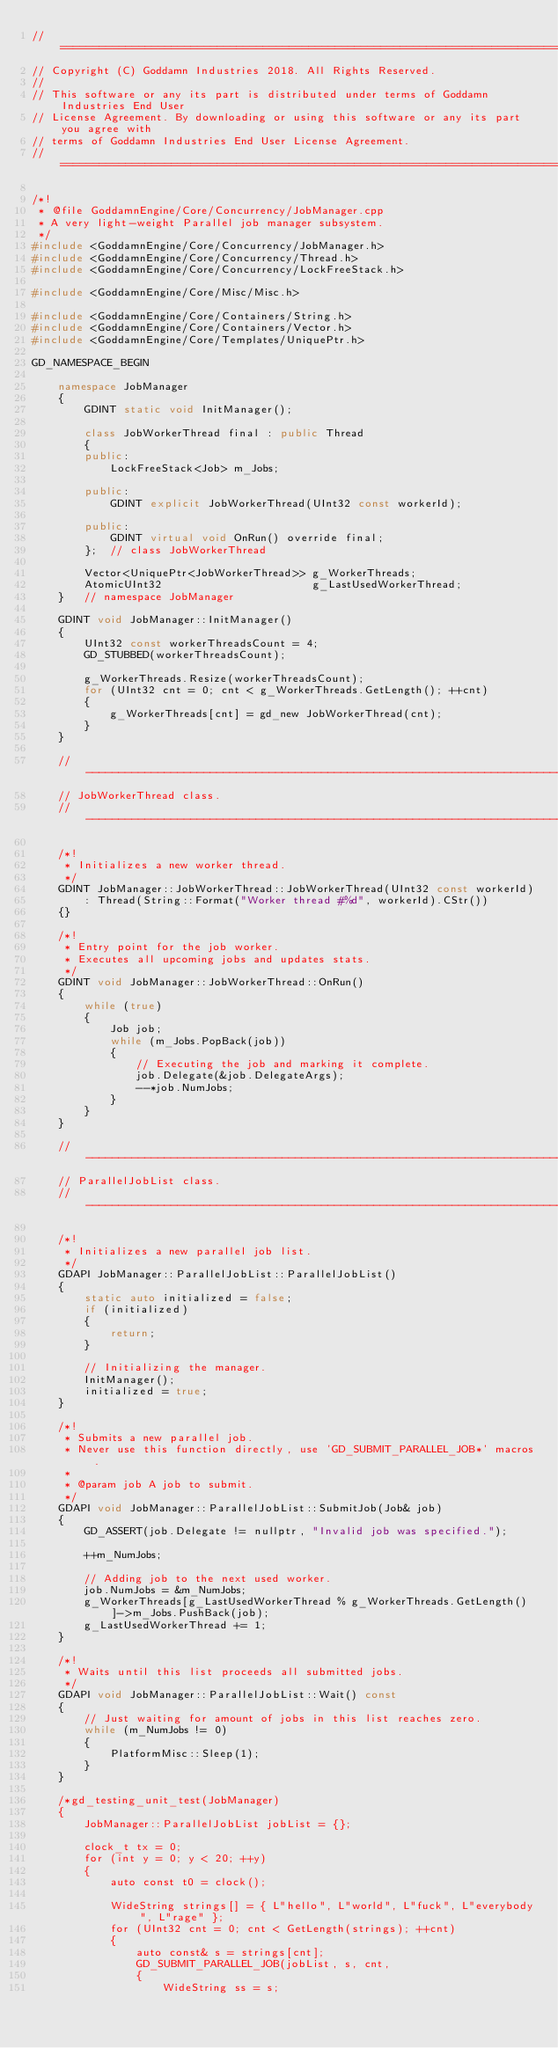Convert code to text. <code><loc_0><loc_0><loc_500><loc_500><_C++_>// ==========================================================================================
// Copyright (C) Goddamn Industries 2018. All Rights Reserved.
// 
// This software or any its part is distributed under terms of Goddamn Industries End User
// License Agreement. By downloading or using this software or any its part you agree with 
// terms of Goddamn Industries End User License Agreement.
// ==========================================================================================

/*!
 * @file GoddamnEngine/Core/Concurrency/JobManager.cpp
 * A very light-weight Parallel job manager subsystem.
 */
#include <GoddamnEngine/Core/Concurrency/JobManager.h>
#include <GoddamnEngine/Core/Concurrency/Thread.h>
#include <GoddamnEngine/Core/Concurrency/LockFreeStack.h>

#include <GoddamnEngine/Core/Misc/Misc.h>

#include <GoddamnEngine/Core/Containers/String.h>
#include <GoddamnEngine/Core/Containers/Vector.h>
#include <GoddamnEngine/Core/Templates/UniquePtr.h>

GD_NAMESPACE_BEGIN

	namespace JobManager
	{
		GDINT static void InitManager();

		class JobWorkerThread final : public Thread
		{
		public:
			LockFreeStack<Job> m_Jobs;

		public:
			GDINT explicit JobWorkerThread(UInt32 const workerId);

		public:
			GDINT virtual void OnRun() override final;
		};	// class JobWorkerThread
		
		Vector<UniquePtr<JobWorkerThread>> g_WorkerThreads;
		AtomicUInt32                       g_LastUsedWorkerThread;
	}	// namespace JobManager

	GDINT void JobManager::InitManager()
	{
		UInt32 const workerThreadsCount = 4;
		GD_STUBBED(workerThreadsCount);

		g_WorkerThreads.Resize(workerThreadsCount);
		for (UInt32 cnt = 0; cnt < g_WorkerThreads.GetLength(); ++cnt)
		{
			g_WorkerThreads[cnt] = gd_new JobWorkerThread(cnt);
		}
	}

	// ------------------------------------------------------------------------------------------
	// JobWorkerThread class.
	// ------------------------------------------------------------------------------------------

	/*!
	 * Initializes a new worker thread.
	 */
	GDINT JobManager::JobWorkerThread::JobWorkerThread(UInt32 const workerId)
		: Thread(String::Format("Worker thread #%d", workerId).CStr())
	{}

	/*!
	 * Entry point for the job worker.
	 * Executes all upcoming jobs and updates stats.
	 */
	GDINT void JobManager::JobWorkerThread::OnRun()
	{
		while (true)
		{
			Job job;
			while (m_Jobs.PopBack(job))
			{
				// Executing the job and marking it complete.
				job.Delegate(&job.DelegateArgs);
				--*job.NumJobs;
			}
		}
	}

	// ------------------------------------------------------------------------------------------
	// ParallelJobList class.
	// ------------------------------------------------------------------------------------------

	/*!
	 * Initializes a new parallel job list.
	 */
	GDAPI JobManager::ParallelJobList::ParallelJobList()
	{
		static auto initialized = false;
		if (initialized)
		{
			return;
		}

		// Initializing the manager.
		InitManager();
		initialized = true;
	}

	/*!
	 * Submits a new parallel job.
	 * Never use this function directly, use 'GD_SUBMIT_PARALLEL_JOB*' macros.
	 *
	 * @param job A job to submit.
	 */
	GDAPI void JobManager::ParallelJobList::SubmitJob(Job& job)
	{
		GD_ASSERT(job.Delegate != nullptr, "Invalid job was specified.");

		++m_NumJobs;

		// Adding job to the next used worker.
		job.NumJobs = &m_NumJobs;
		g_WorkerThreads[g_LastUsedWorkerThread % g_WorkerThreads.GetLength()]->m_Jobs.PushBack(job);
		g_LastUsedWorkerThread += 1;
	}

	/*!
	 * Waits until this list proceeds all submitted jobs. 
	 */
	GDAPI void JobManager::ParallelJobList::Wait() const
	{
		// Just waiting for amount of jobs in this list reaches zero. 
		while (m_NumJobs != 0)
		{
			PlatformMisc::Sleep(1);
		}
	}

	/*gd_testing_unit_test(JobManager)
	{
		JobManager::ParallelJobList jobList = {};

		clock_t tx = 0;
		for (int y = 0; y < 20; ++y)
		{
			auto const t0 = clock();

			WideString strings[] = { L"hello", L"world", L"fuck", L"everybody", L"rage" };
			for (UInt32 cnt = 0; cnt < GetLength(strings); ++cnt)
			{
				auto const& s = strings[cnt];
				GD_SUBMIT_PARALLEL_JOB(jobList, s, cnt,
				{
					WideString ss = s;</code> 